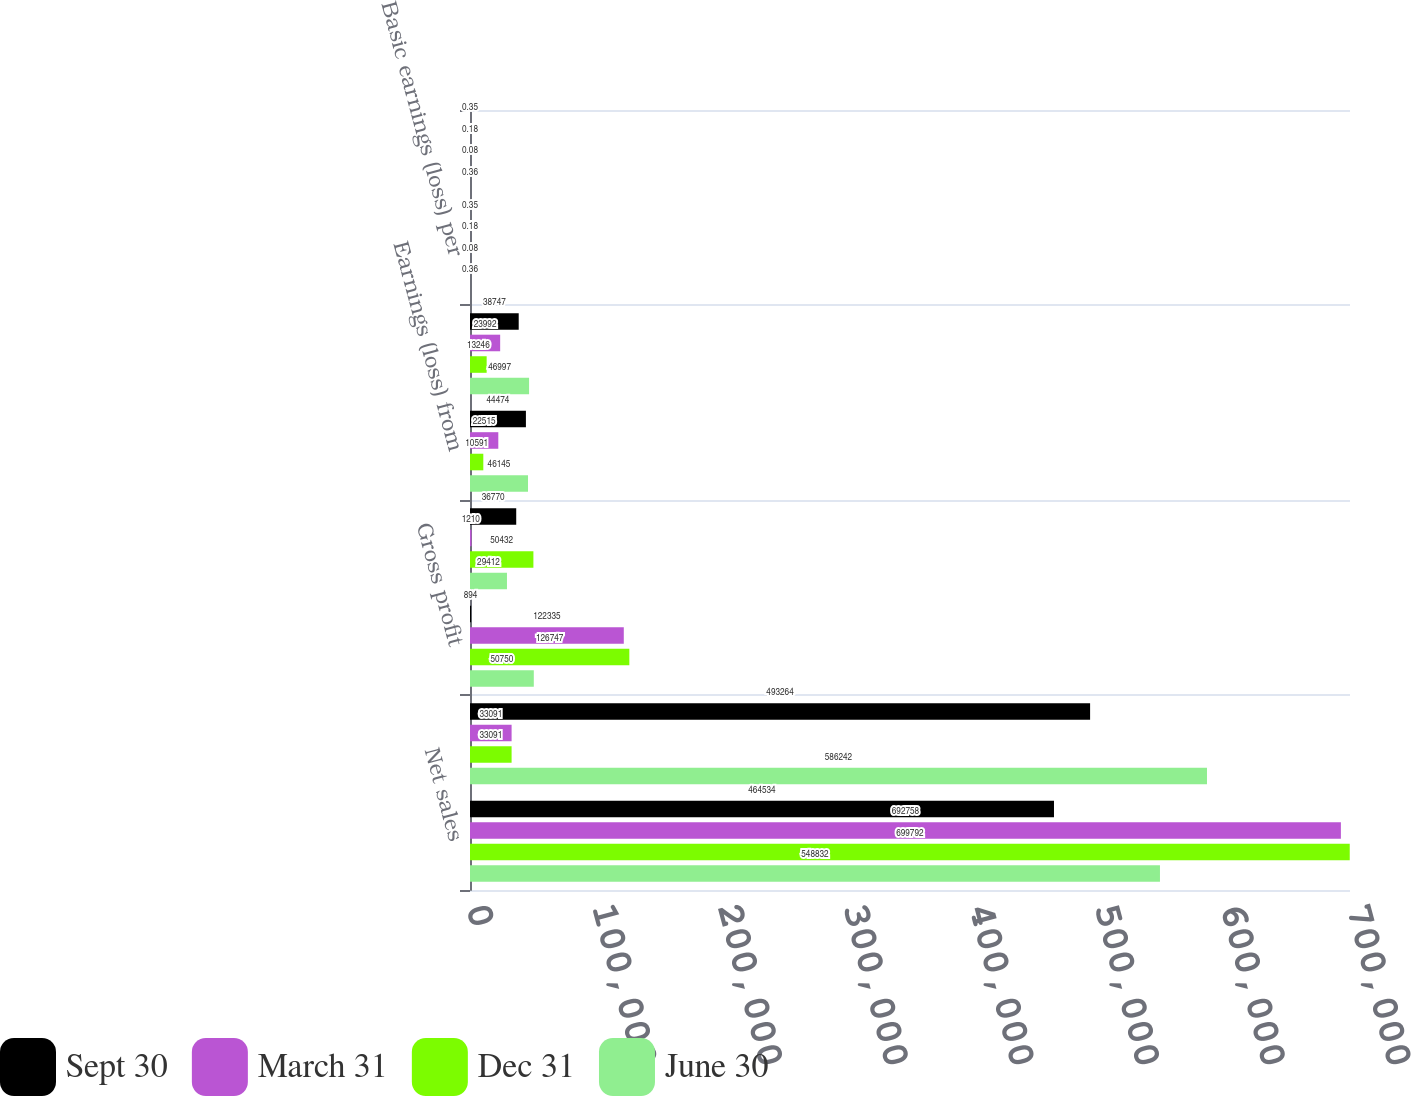<chart> <loc_0><loc_0><loc_500><loc_500><stacked_bar_chart><ecel><fcel>Net sales<fcel>Total revenues<fcel>Gross profit<fcel>Operating earnings (loss)<fcel>Earnings (loss) from<fcel>Net earnings (loss)<fcel>Basic earnings (loss) per<fcel>Diluted earnings (loss) per<nl><fcel>Sept 30<fcel>464534<fcel>493264<fcel>894<fcel>36770<fcel>44474<fcel>38747<fcel>0.35<fcel>0.35<nl><fcel>March 31<fcel>692758<fcel>33091<fcel>122335<fcel>1210<fcel>22515<fcel>23992<fcel>0.18<fcel>0.18<nl><fcel>Dec 31<fcel>699792<fcel>33091<fcel>126747<fcel>50432<fcel>10591<fcel>13246<fcel>0.08<fcel>0.08<nl><fcel>June 30<fcel>548832<fcel>586242<fcel>50750<fcel>29412<fcel>46145<fcel>46997<fcel>0.36<fcel>0.36<nl></chart> 